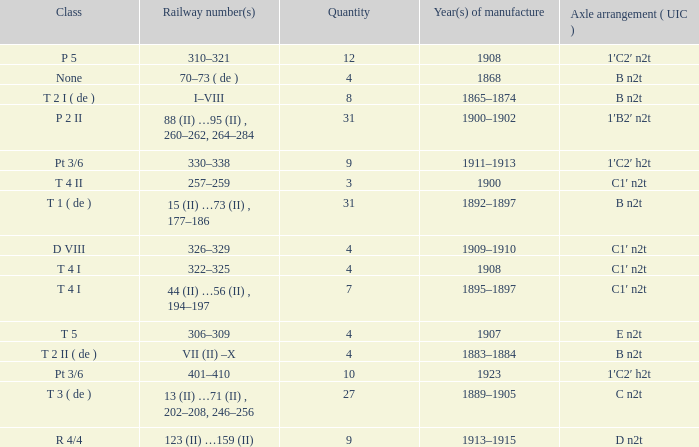What year was the b n2t axle arrangement, which has a quantity of 31, manufactured? 1892–1897. 